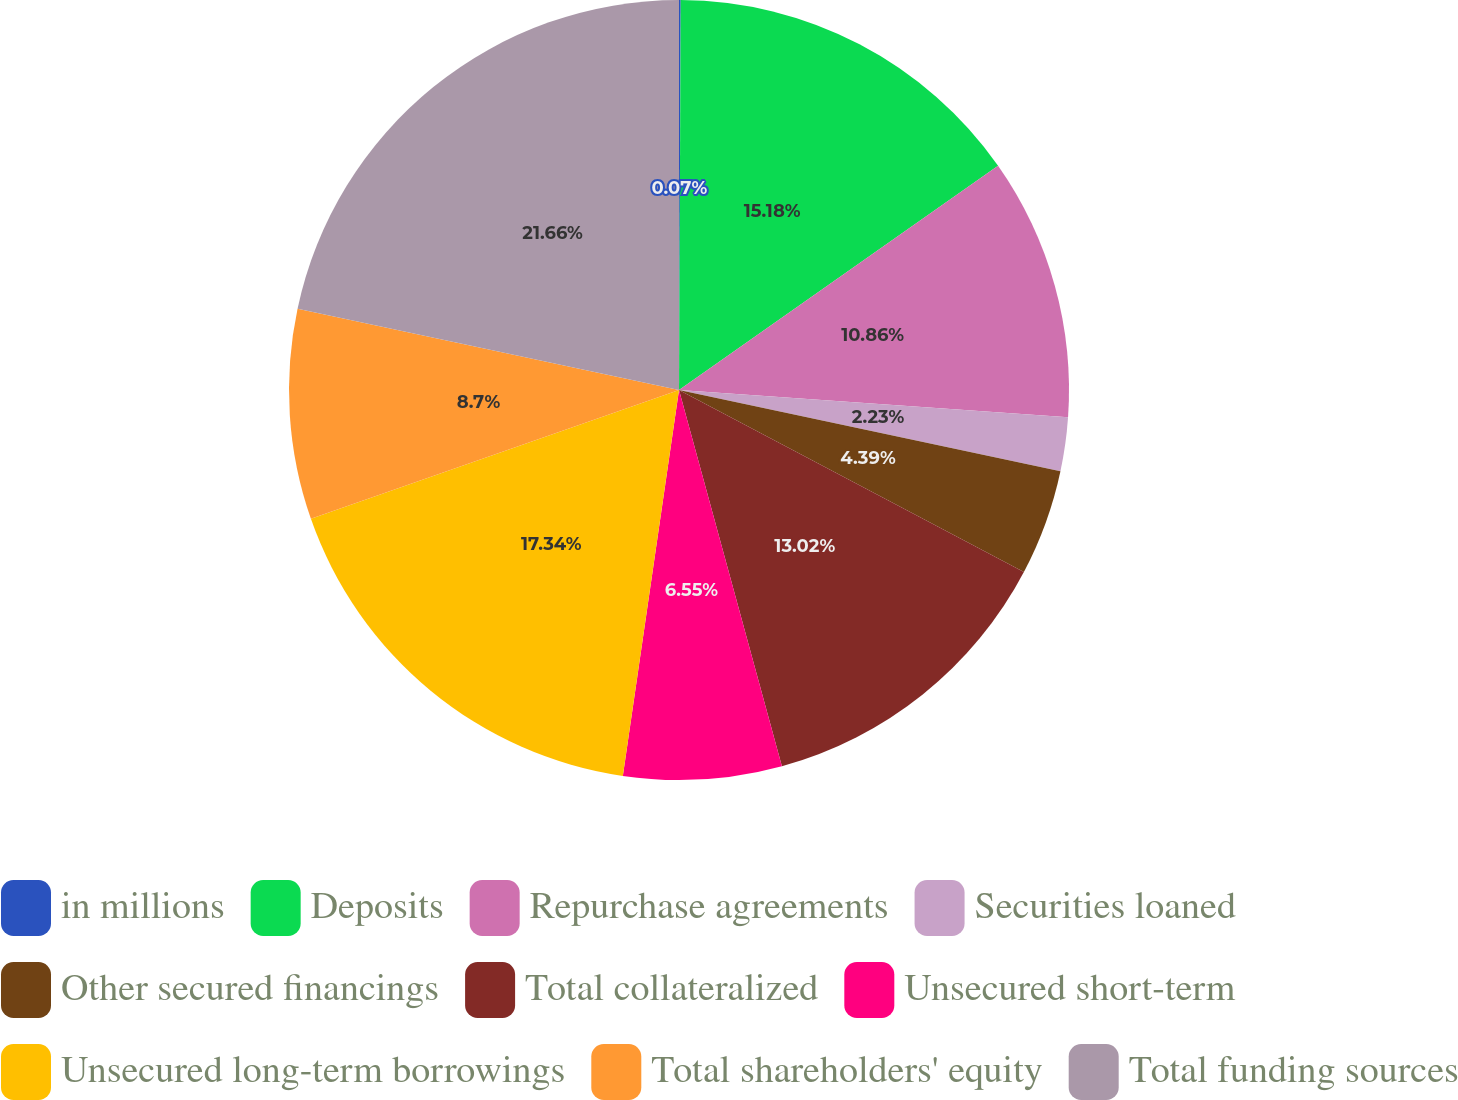Convert chart to OTSL. <chart><loc_0><loc_0><loc_500><loc_500><pie_chart><fcel>in millions<fcel>Deposits<fcel>Repurchase agreements<fcel>Securities loaned<fcel>Other secured financings<fcel>Total collateralized<fcel>Unsecured short-term<fcel>Unsecured long-term borrowings<fcel>Total shareholders' equity<fcel>Total funding sources<nl><fcel>0.07%<fcel>15.18%<fcel>10.86%<fcel>2.23%<fcel>4.39%<fcel>13.02%<fcel>6.55%<fcel>17.34%<fcel>8.7%<fcel>21.66%<nl></chart> 